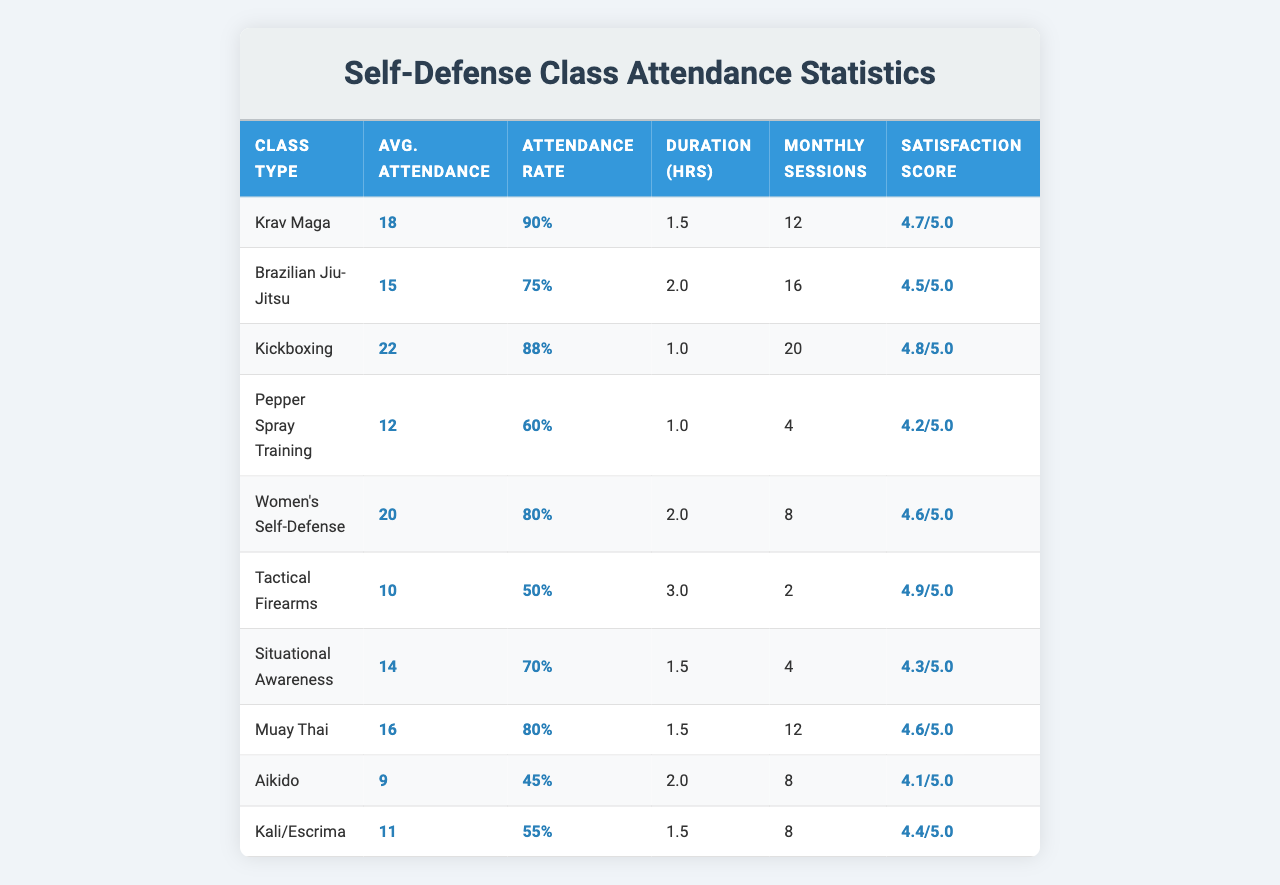What is the average attendance for Krav Maga classes? The table lists the average attendance for each class type. For Krav Maga, the average attendance is stated as 18.
Answer: 18 Which class has the highest attendance rate? Looking at the attendance rates, Krav Maga has the highest attendance rate at 90%.
Answer: Krav Maga How many monthly sessions does Tactical Firearms have? The table shows that Tactical Firearms has 2 monthly sessions listed.
Answer: 2 What is the customer satisfaction score for Brazilian Jiu-Jitsu? The customer satisfaction score for Brazilian Jiu-Jitsu in the table is listed as 4.5.
Answer: 4.5 Which class type has the longest duration? By checking the class duration hours, Tactical Firearms has the longest duration of 3 hours.
Answer: Tactical Firearms What is the average attendance for all classes combined? To find the average attendance, sum the average attendance values (18 + 15 + 22 + 12 + 20 + 10 + 14 + 16 + 9 + 11), which equals  7 + 5 + 6 + 4 = 7 + 1 = 156. Since there are 10 classes, divide by 10 to get 156/10 = 15.6.
Answer: 15.6 Does any class have an attendance rate below 50%? Looking at the attendance rates, Tactical Firearms (50%) and Aikido (45%) do indeed fall below this threshold.
Answer: Yes What is the difference in average attendance between Kickboxing and Women's Self-Defense classes? Average attendance for Kickboxing is 22 and for Women's Self-Defense is 20. The difference is 22 - 20 = 2.
Answer: 2 If a customer wants to select a class with both high attendance and high customer satisfaction, which class should they choose? Checking the table, Krav Maga has the highest average attendance (18) and a satisfaction score of 4.7, making it the best choice.
Answer: Krav Maga What is the total number of monthly sessions for all classes combined? To calculate the total monthly sessions, sum the monthly sessions: (12 + 16 + 20 + 4 + 8 + 2 + 4 + 12 + 8 + 8) = 94 sessions total.
Answer: 94 